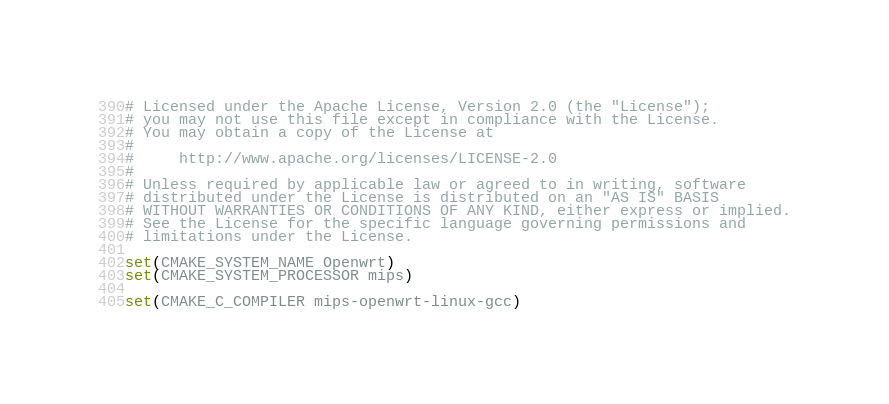Convert code to text. <code><loc_0><loc_0><loc_500><loc_500><_CMake_># Licensed under the Apache License, Version 2.0 (the "License");
# you may not use this file except in compliance with the License.
# You may obtain a copy of the License at
#
#     http://www.apache.org/licenses/LICENSE-2.0
#
# Unless required by applicable law or agreed to in writing, software
# distributed under the License is distributed on an "AS IS" BASIS
# WITHOUT WARRANTIES OR CONDITIONS OF ANY KIND, either express or implied.
# See the License for the specific language governing permissions and
# limitations under the License.

set(CMAKE_SYSTEM_NAME Openwrt)
set(CMAKE_SYSTEM_PROCESSOR mips)

set(CMAKE_C_COMPILER mips-openwrt-linux-gcc)
</code> 